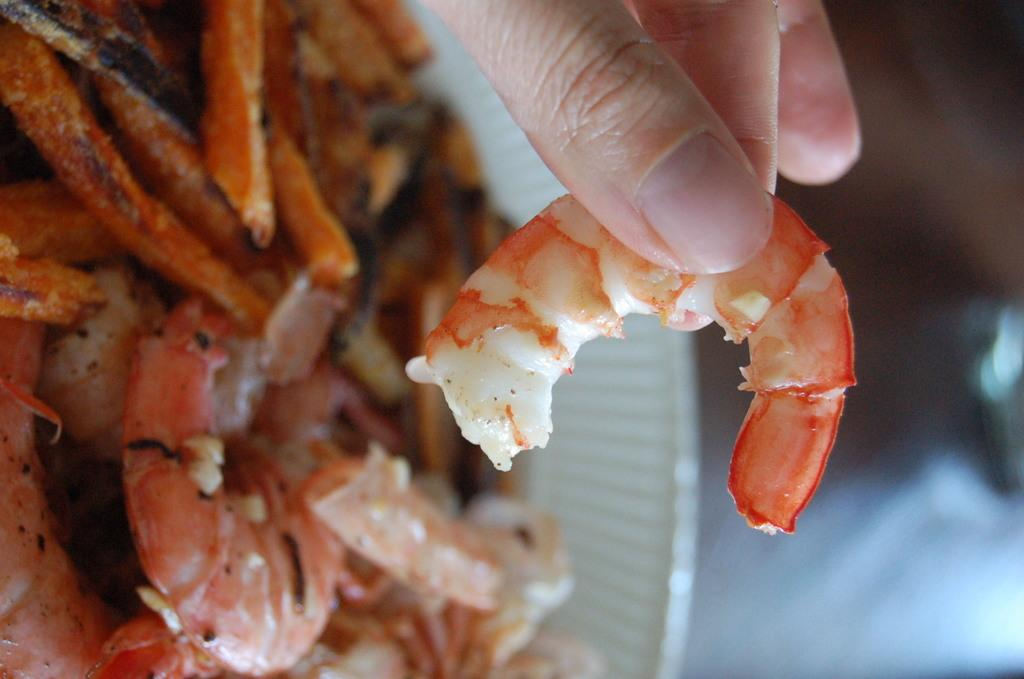What is the main object in the center of the image? There is a plate in the center of the image. What is on the plate? There is a food item on the plate. Can you describe the human hand in the image? There is a human hand holding a food item in the image. How many bikes are parked next to the plate in the image? There are no bikes present in the image. What type of beetle can be seen crawling on the food item on the plate? There are no beetles present on the food item in the image. 